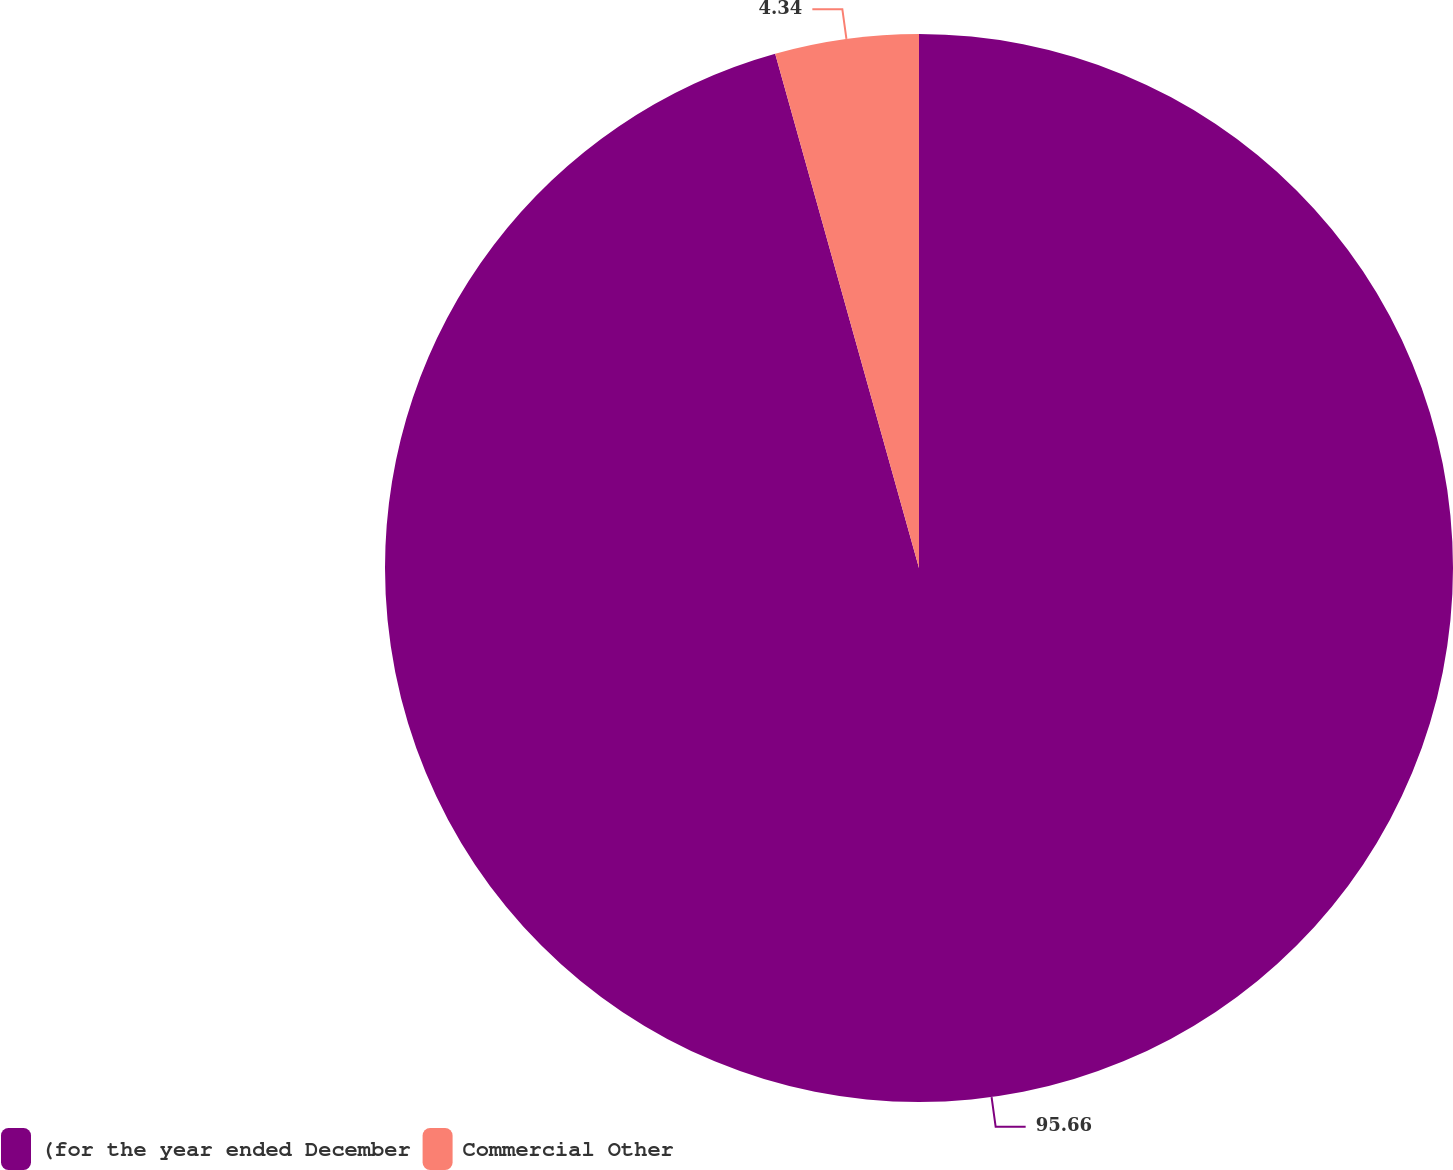<chart> <loc_0><loc_0><loc_500><loc_500><pie_chart><fcel>(for the year ended December<fcel>Commercial Other<nl><fcel>95.66%<fcel>4.34%<nl></chart> 